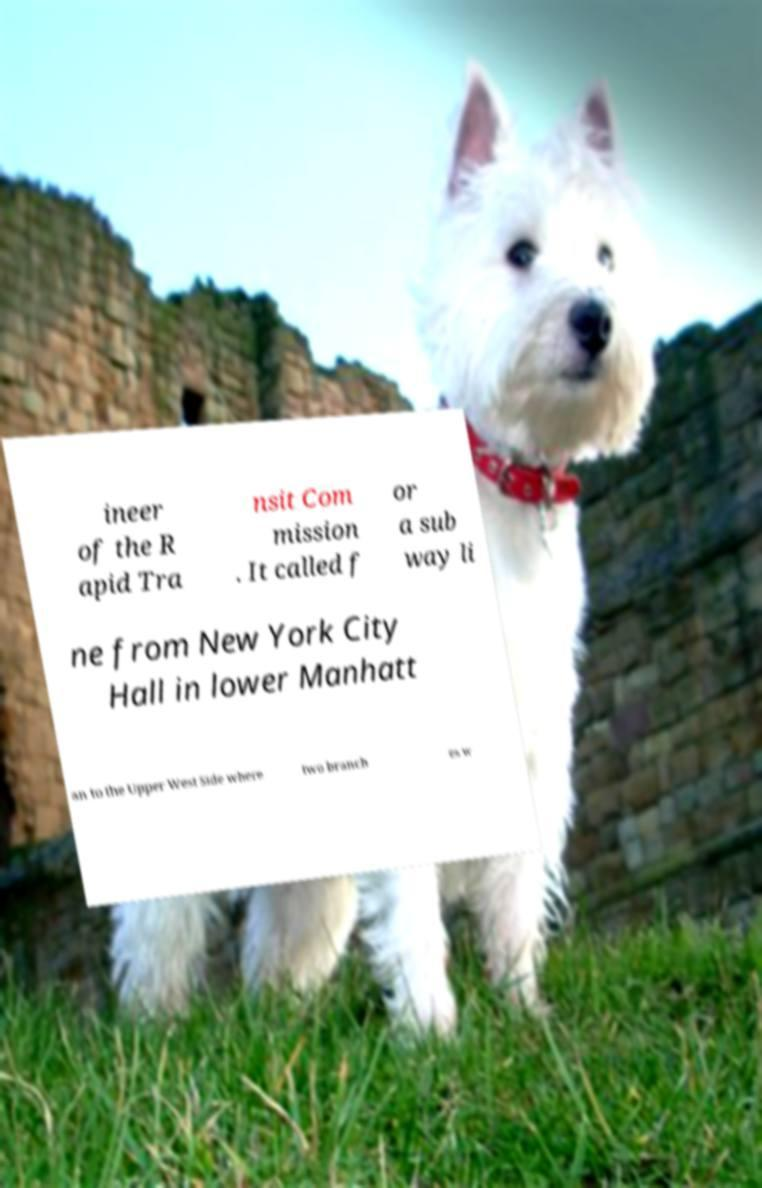What messages or text are displayed in this image? I need them in a readable, typed format. ineer of the R apid Tra nsit Com mission . It called f or a sub way li ne from New York City Hall in lower Manhatt an to the Upper West Side where two branch es w 